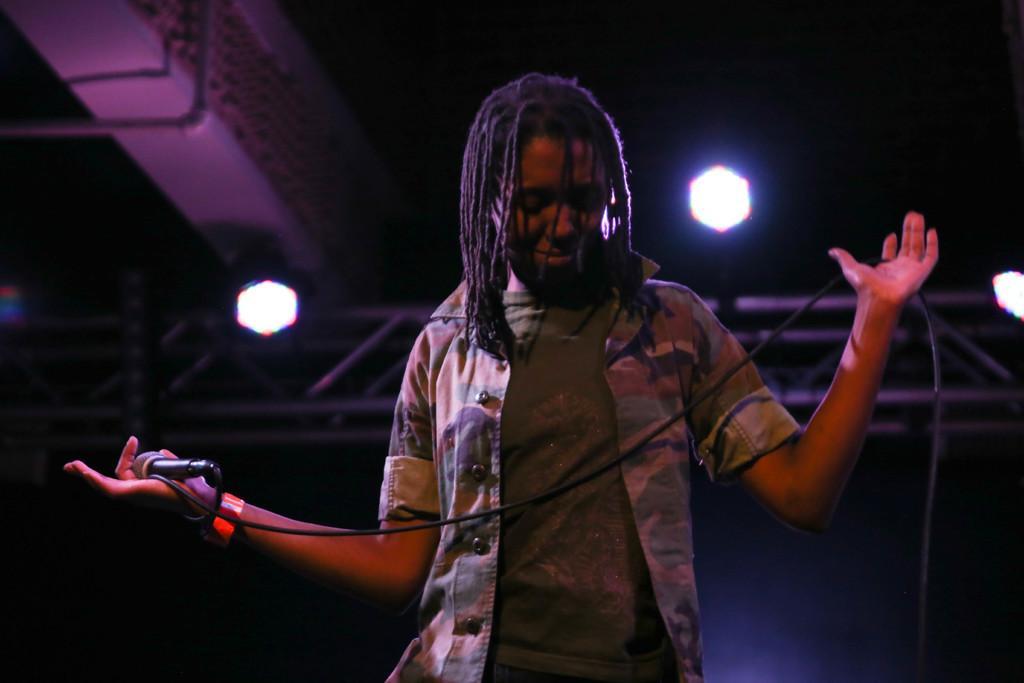In one or two sentences, can you explain what this image depicts? In this picture there is a person standing and holding a mic in his hands and there are two lights behind him. 